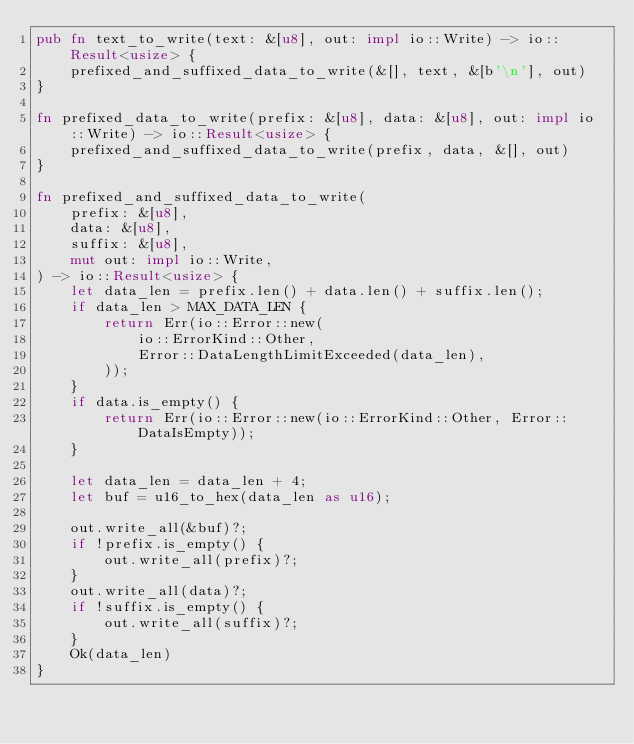<code> <loc_0><loc_0><loc_500><loc_500><_Rust_>pub fn text_to_write(text: &[u8], out: impl io::Write) -> io::Result<usize> {
    prefixed_and_suffixed_data_to_write(&[], text, &[b'\n'], out)
}

fn prefixed_data_to_write(prefix: &[u8], data: &[u8], out: impl io::Write) -> io::Result<usize> {
    prefixed_and_suffixed_data_to_write(prefix, data, &[], out)
}

fn prefixed_and_suffixed_data_to_write(
    prefix: &[u8],
    data: &[u8],
    suffix: &[u8],
    mut out: impl io::Write,
) -> io::Result<usize> {
    let data_len = prefix.len() + data.len() + suffix.len();
    if data_len > MAX_DATA_LEN {
        return Err(io::Error::new(
            io::ErrorKind::Other,
            Error::DataLengthLimitExceeded(data_len),
        ));
    }
    if data.is_empty() {
        return Err(io::Error::new(io::ErrorKind::Other, Error::DataIsEmpty));
    }

    let data_len = data_len + 4;
    let buf = u16_to_hex(data_len as u16);

    out.write_all(&buf)?;
    if !prefix.is_empty() {
        out.write_all(prefix)?;
    }
    out.write_all(data)?;
    if !suffix.is_empty() {
        out.write_all(suffix)?;
    }
    Ok(data_len)
}
</code> 